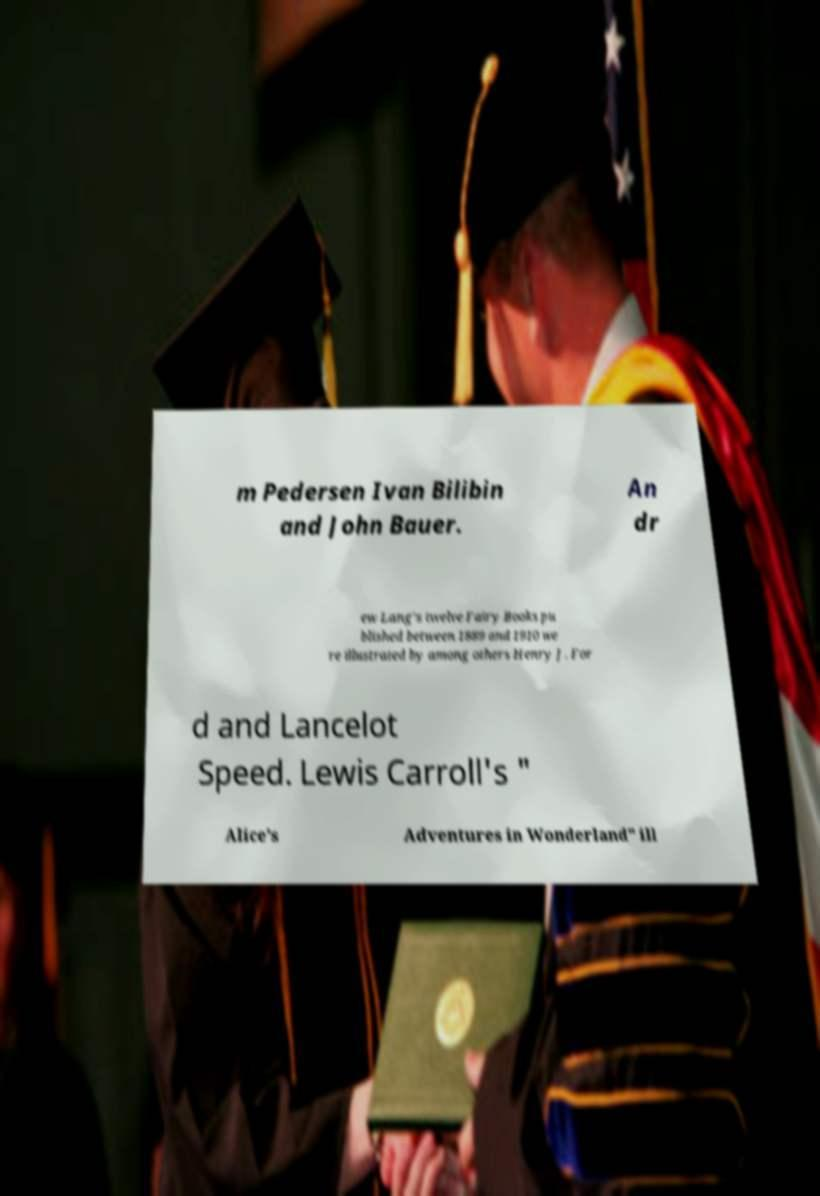Please identify and transcribe the text found in this image. m Pedersen Ivan Bilibin and John Bauer. An dr ew Lang's twelve Fairy Books pu blished between 1889 and 1910 we re illustrated by among others Henry J. For d and Lancelot Speed. Lewis Carroll's " Alice's Adventures in Wonderland" ill 